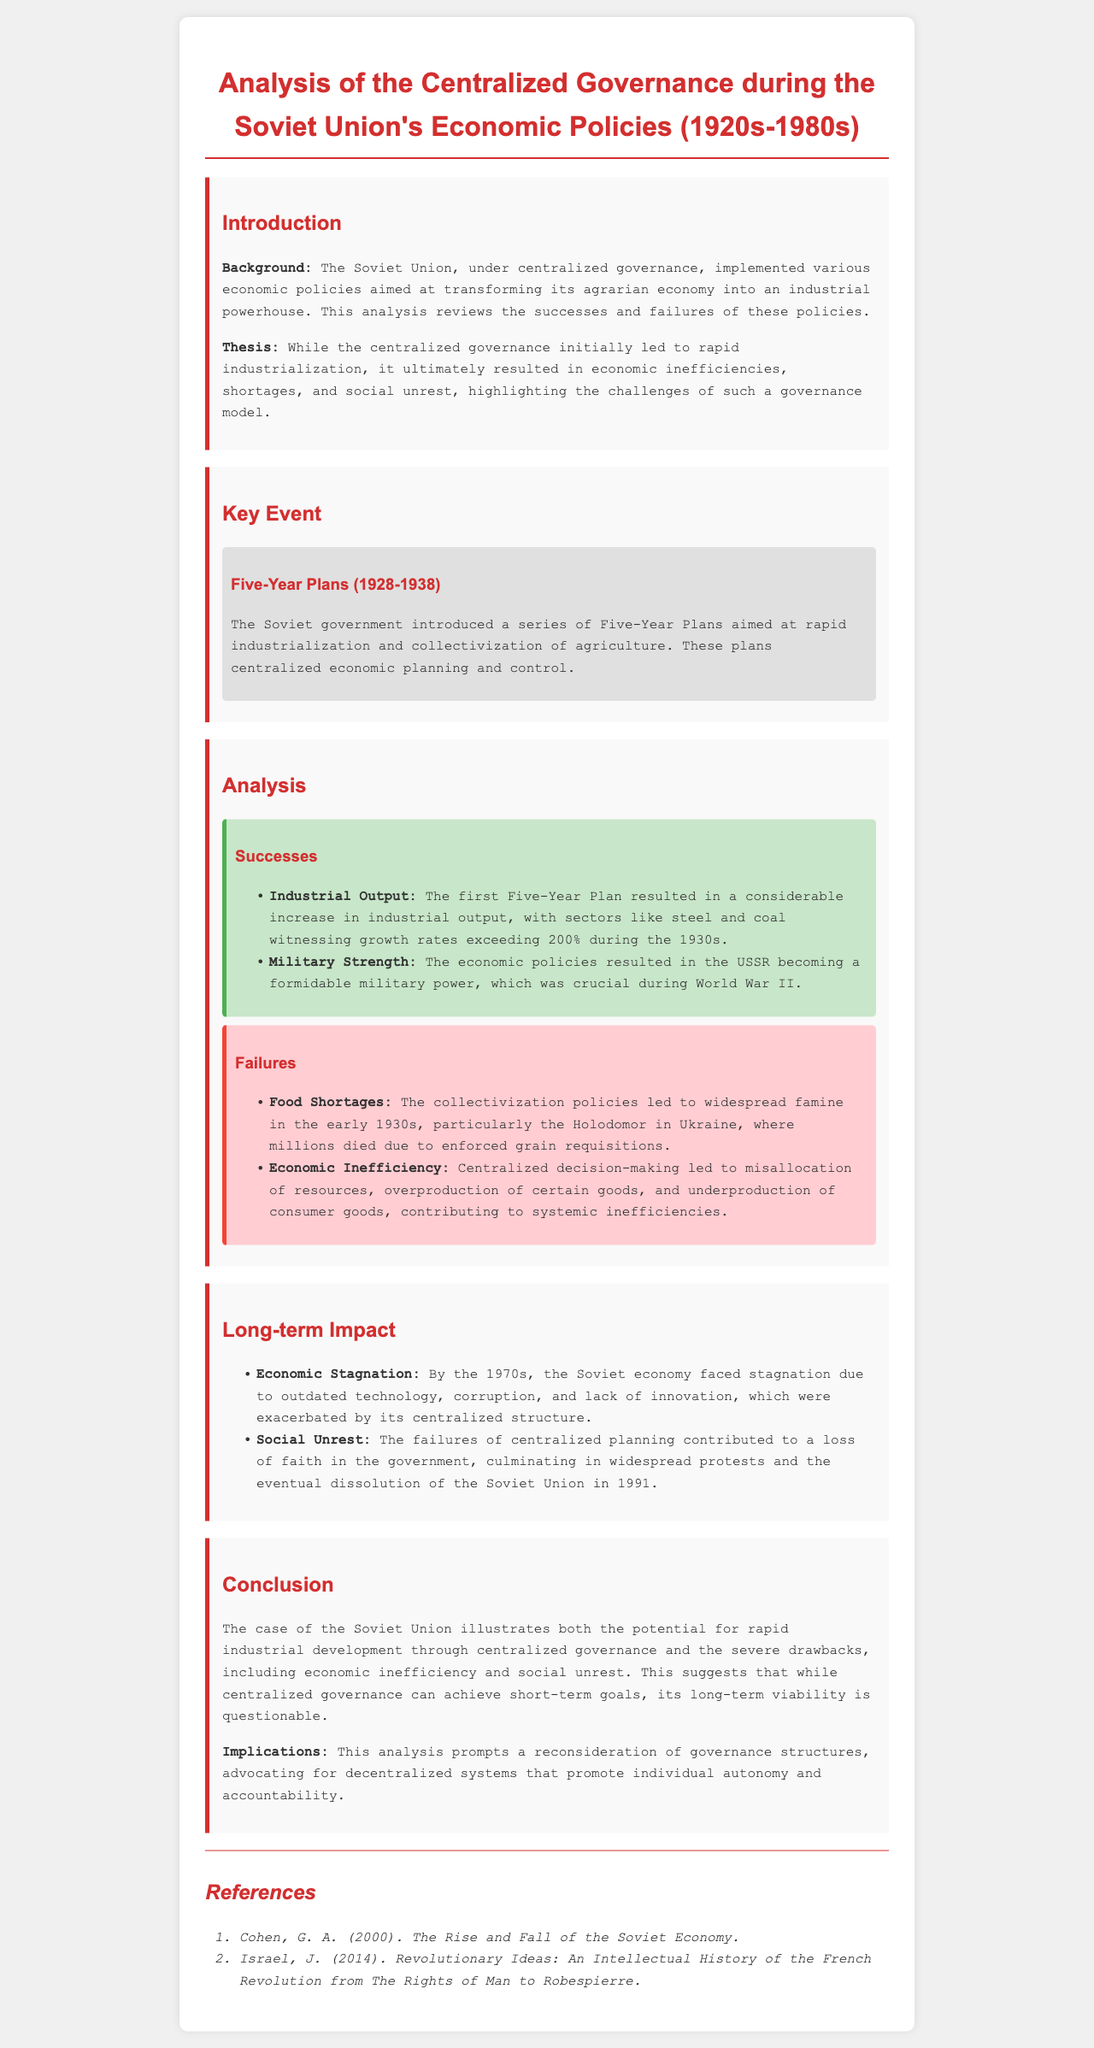What was the time period analyzed in the document? The document focuses on the Soviet Union’s economic policies from the 1920s to the 1980s.
Answer: 1920s-1980s What were the main economic plans introduced by the Soviet government? The document describes the implementation of a series of Five-Year Plans.
Answer: Five-Year Plans What was one major success of the first Five-Year Plan? A specific success mentioned is an increase in industrial output exceeding 200% in certain sectors during the 1930s.
Answer: Industrial output increase What catastrophic event is associated with the collectivization policies? The document highlights the Holodomor as a significant famine resulting from these policies.
Answer: Holodomor What long-term impact did centralized governance have on the Soviet economy by the 1970s? Centralized governance led to economic stagnation due to outdated technology and corruption.
Answer: Economic stagnation What were the implications of the analysis presented in the document? The document suggests a reconsideration of governance structures towards decentralized systems promoting individual autonomy.
Answer: Decentralized systems What was a significant military outcome of the economic policies? The document states that the economic policies resulted in the USSR becoming a formidable military power.
Answer: Formidable military power In what year did the Soviet Union dissolve? According to the document, widespread protests stemming from governance failures contributed to the dissolution in 1991.
Answer: 1991 